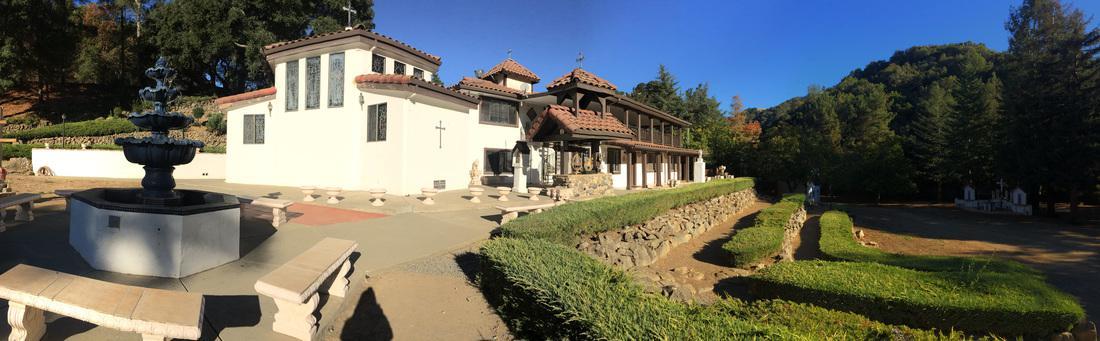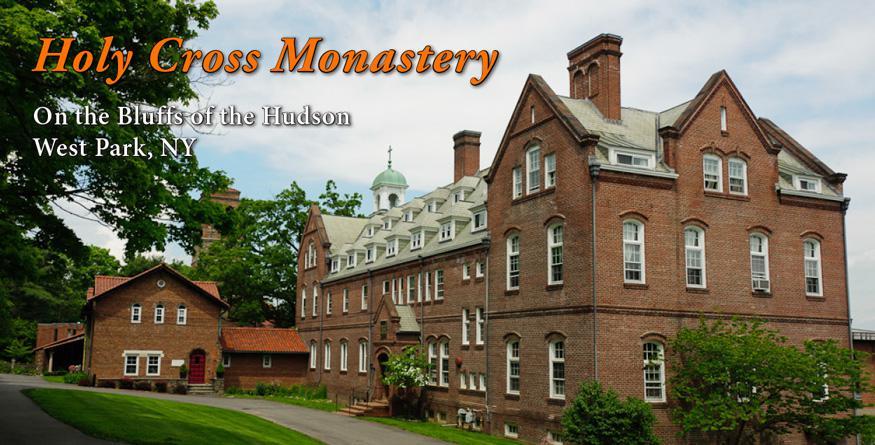The first image is the image on the left, the second image is the image on the right. Evaluate the accuracy of this statement regarding the images: "The wooden sign is for a monastary.". Is it true? Answer yes or no. No. 